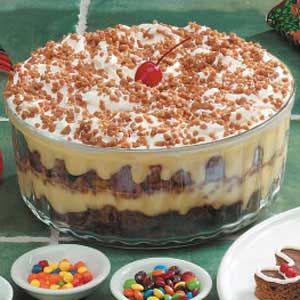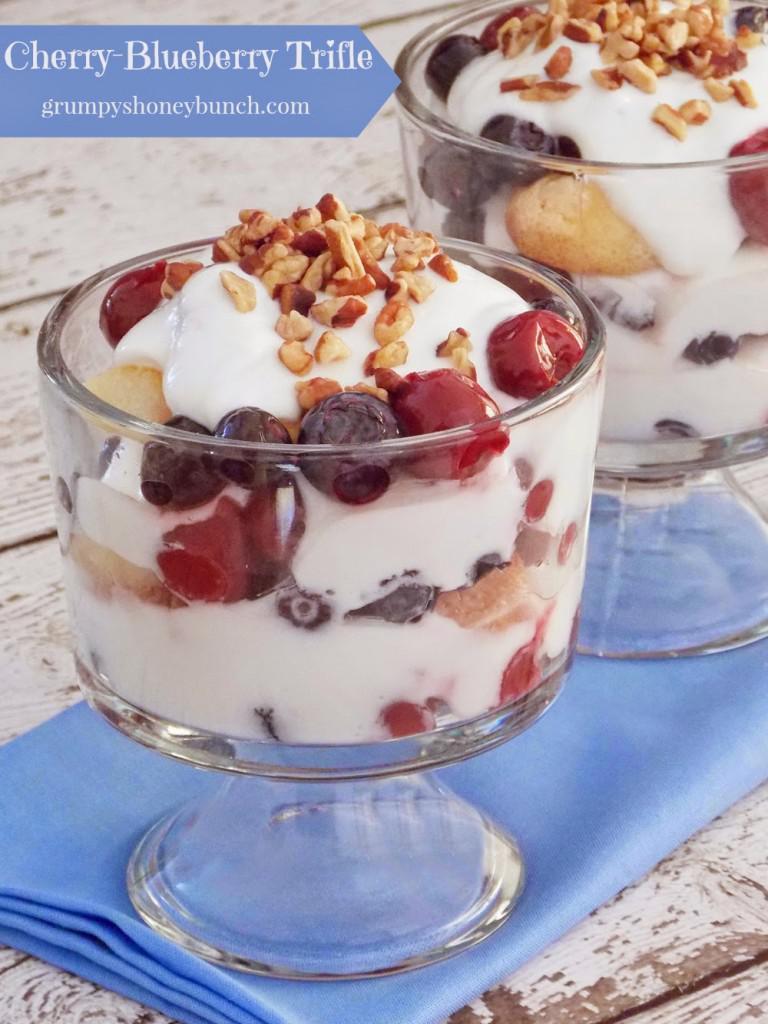The first image is the image on the left, the second image is the image on the right. Examine the images to the left and right. Is the description "cream layered desserts with at least 1 cherry on top" accurate? Answer yes or no. Yes. The first image is the image on the left, the second image is the image on the right. Analyze the images presented: Is the assertion "The image on the left shows a single bowl of trifle while the image on the right shows two pedestal bowls of trifle." valid? Answer yes or no. Yes. 